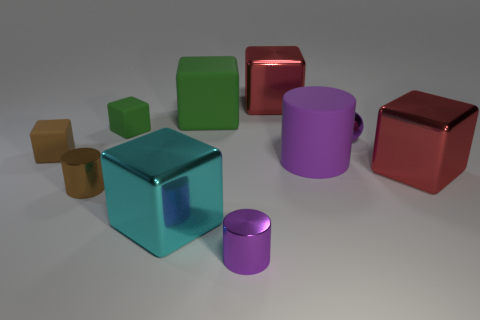There is a small block that is on the right side of the brown rubber object; is its color the same as the big rubber block?
Your answer should be very brief. Yes. Are there fewer small purple metal balls on the left side of the tiny green thing than large purple cylinders?
Your response must be concise. Yes. There is a small object that is the same material as the brown block; what color is it?
Your response must be concise. Green. What size is the purple metallic object that is right of the purple metallic cylinder?
Your answer should be compact. Small. Do the big cyan block and the tiny brown cylinder have the same material?
Offer a very short reply. Yes. Are there any big red shiny things that are behind the purple cylinder that is in front of the metallic block left of the tiny purple cylinder?
Your response must be concise. Yes. The large cylinder is what color?
Keep it short and to the point. Purple. There is a matte block that is the same size as the cyan shiny block; what is its color?
Provide a succinct answer. Green. There is a green thing to the right of the large cyan object; is it the same shape as the brown metal object?
Your answer should be very brief. No. What color is the large shiny cube that is in front of the large red object that is to the right of the big metal block behind the small brown matte thing?
Your answer should be compact. Cyan. 